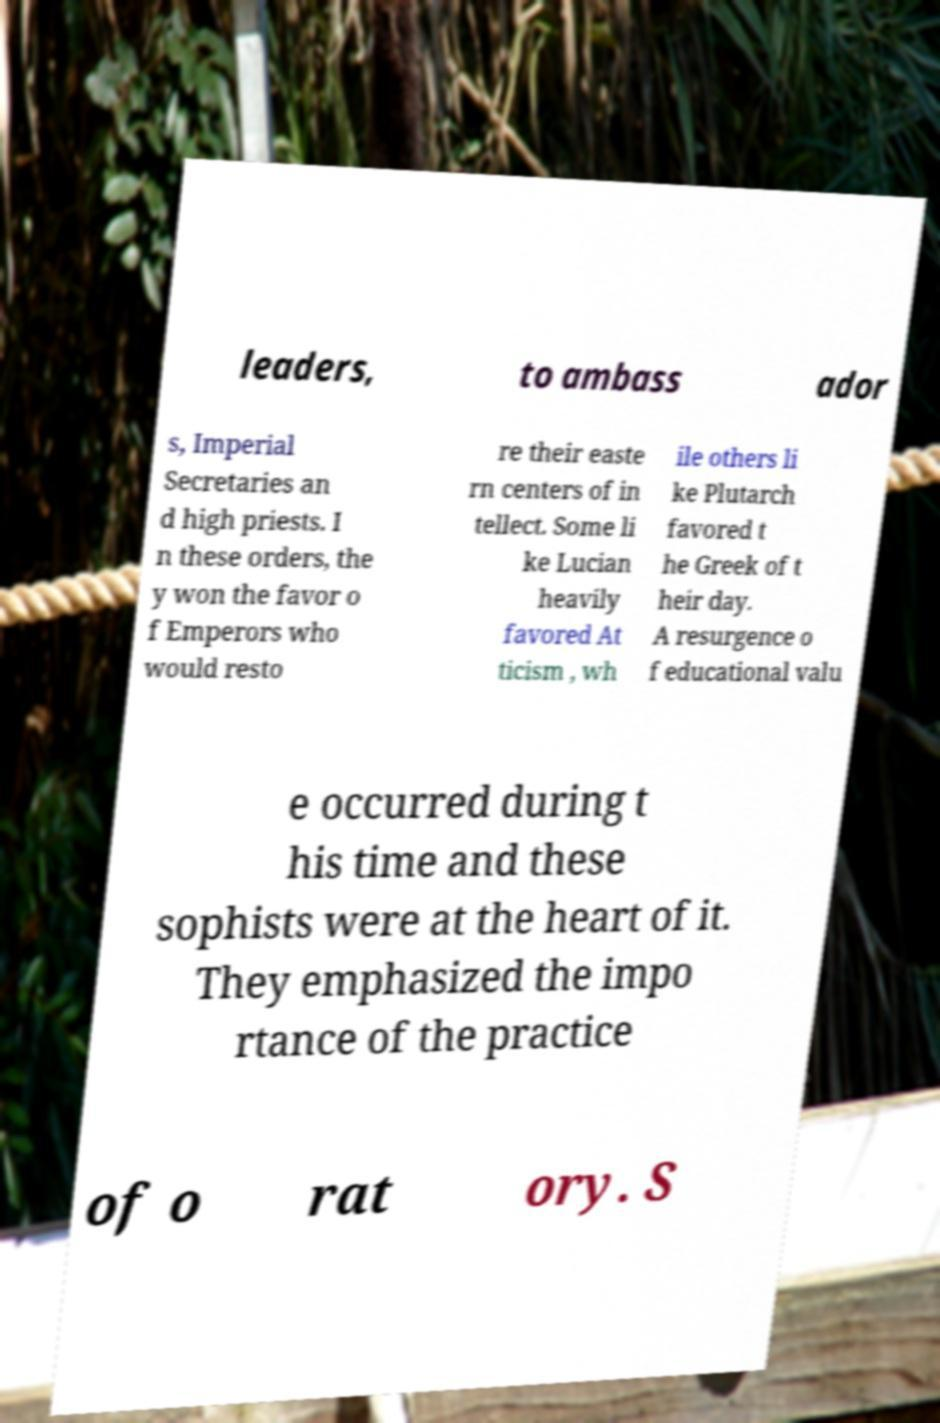What messages or text are displayed in this image? I need them in a readable, typed format. leaders, to ambass ador s, Imperial Secretaries an d high priests. I n these orders, the y won the favor o f Emperors who would resto re their easte rn centers of in tellect. Some li ke Lucian heavily favored At ticism , wh ile others li ke Plutarch favored t he Greek of t heir day. A resurgence o f educational valu e occurred during t his time and these sophists were at the heart of it. They emphasized the impo rtance of the practice of o rat ory. S 